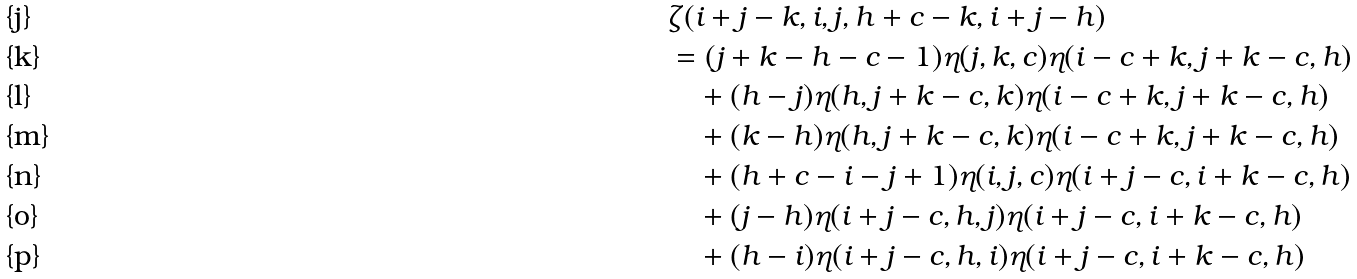<formula> <loc_0><loc_0><loc_500><loc_500>& \zeta ( i + j - k , i , j , h + c - k , i + j - h ) \\ & = ( j + k - h - c - 1 ) \eta ( j , k , c ) \eta ( i - c + k , j + k - c , h ) \\ & \quad + ( h - j ) \eta ( h , j + k - c , k ) \eta ( i - c + k , j + k - c , h ) \\ & \quad + ( k - h ) \eta ( h , j + k - c , k ) \eta ( i - c + k , j + k - c , h ) \\ & \quad + ( h + c - i - j + 1 ) \eta ( i , j , c ) \eta ( i + j - c , i + k - c , h ) \\ & \quad + ( j - h ) \eta ( i + j - c , h , j ) \eta ( i + j - c , i + k - c , h ) \\ & \quad + ( h - i ) \eta ( i + j - c , h , i ) \eta ( i + j - c , i + k - c , h )</formula> 